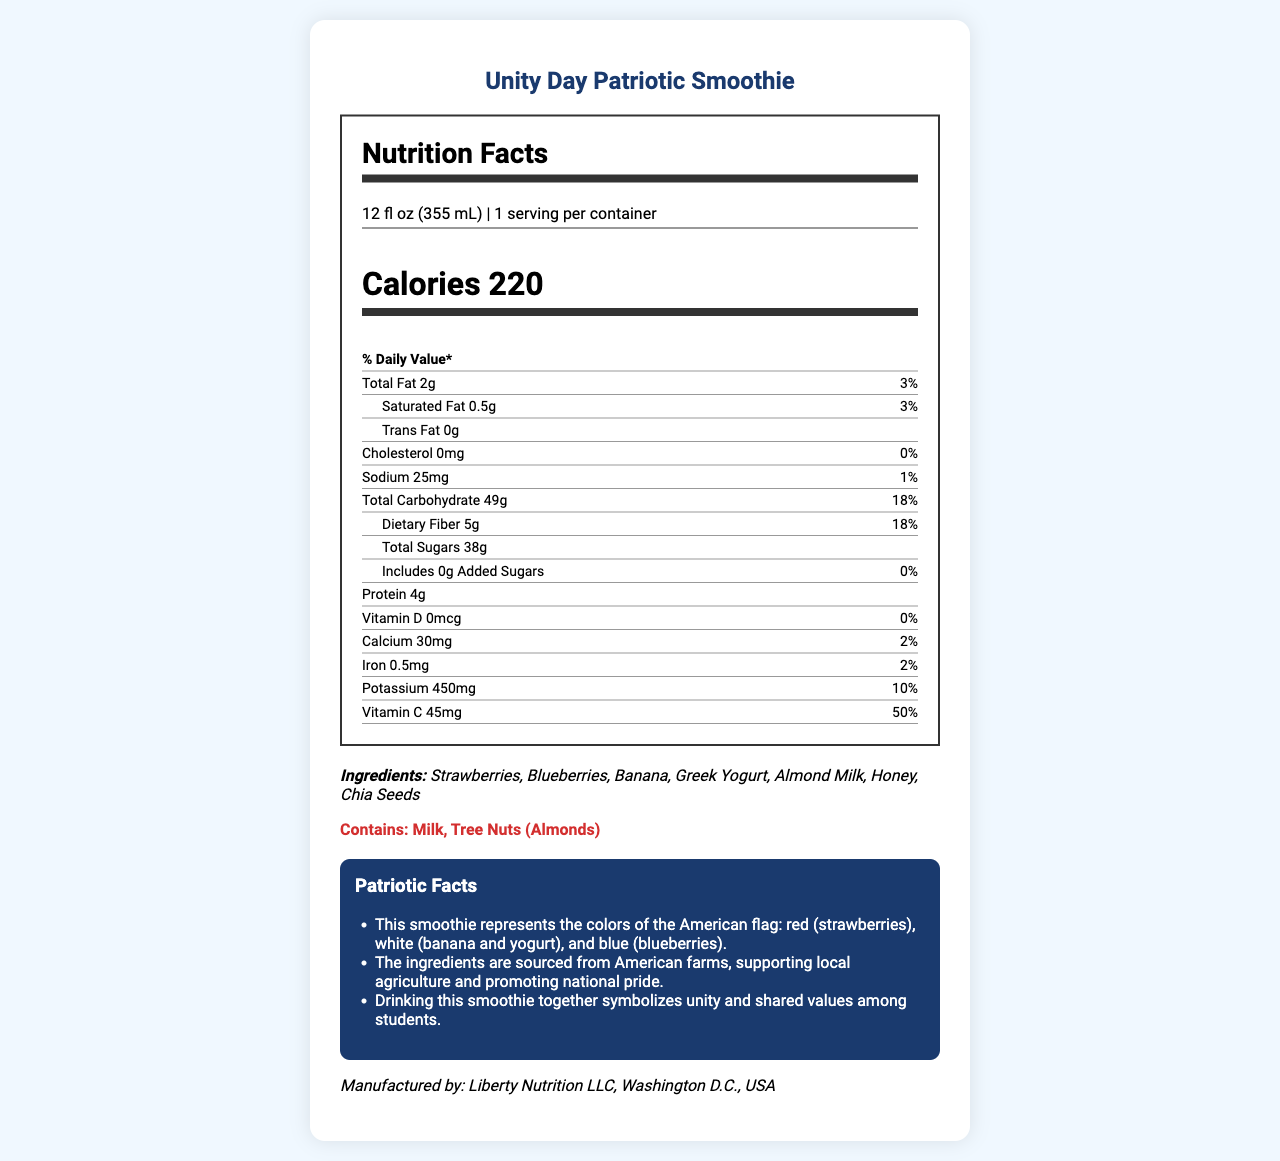what is the serving size? The document lists the serving size as 12 fl oz (355 mL) right at the beginning of the nutrition label.
Answer: 12 fl oz (355 mL) how many calories are in one serving? The calories count is prominently displayed as 220 under the Nutrition Facts heading.
Answer: 220 what are the main ingredients in the Unity Day Patriotic Smoothie? The ingredients section lists these seven items as the main components.
Answer: Strawberries, Blueberries, Banana, Greek Yogurt, Almond Milk, Honey, Chia Seeds what percentage of the daily value of Vitamin C does one serving provide? The amount and daily value percentage of Vitamin C are given as 45mg and 50%, respectively.
Answer: 50% what is the total carbohydrate content in one serving? The total carbohydrate content is specified as 49g.
Answer: 49g is this smoothie suitable for someone with a nut allergy? The allergen information specifies that it contains Tree Nuts (Almonds).
Answer: No summarize the document. The summary explanation captures the main details including nutritional information, ingredients, allergen info, and the patriotic and educational notes about the product.
Answer: The document provides nutrition facts for a "Unity Day Patriotic Smoothie," including serving size, calories, and various nutrient amounts such as fats, carbohydrates, and vitamins. It lists ingredients and allergen information and highlights the patriotic aspect of the smoothie, noting its red, white, and blue colors, its support for American farms, and its symbolism of unity. The document also details the health benefits of the ingredients. how should the smoothie be prepared? The preparation instructions clearly state to blend all ingredients until smooth and serve chilled.
Answer: Blend all ingredients until smooth. Serve chilled and enjoy with fellow Americans! who manufactures this smoothie? The manufacturer is listed at the bottom of the document.
Answer: Liberty Nutrition LLC, Washington D.C., USA what is the total amount of sugars in one serving? The total sugars content is stated as 38g.
Answer: 38g can we determine the exact farms where the ingredients are sourced from? The document mentions that ingredients are sourced from American farms but does not provide specific details on the exact farms.
Answer: Not enough information how much protein does one serving provide? The protein content is given as 4g on the nutrition label.
Answer: 4g 